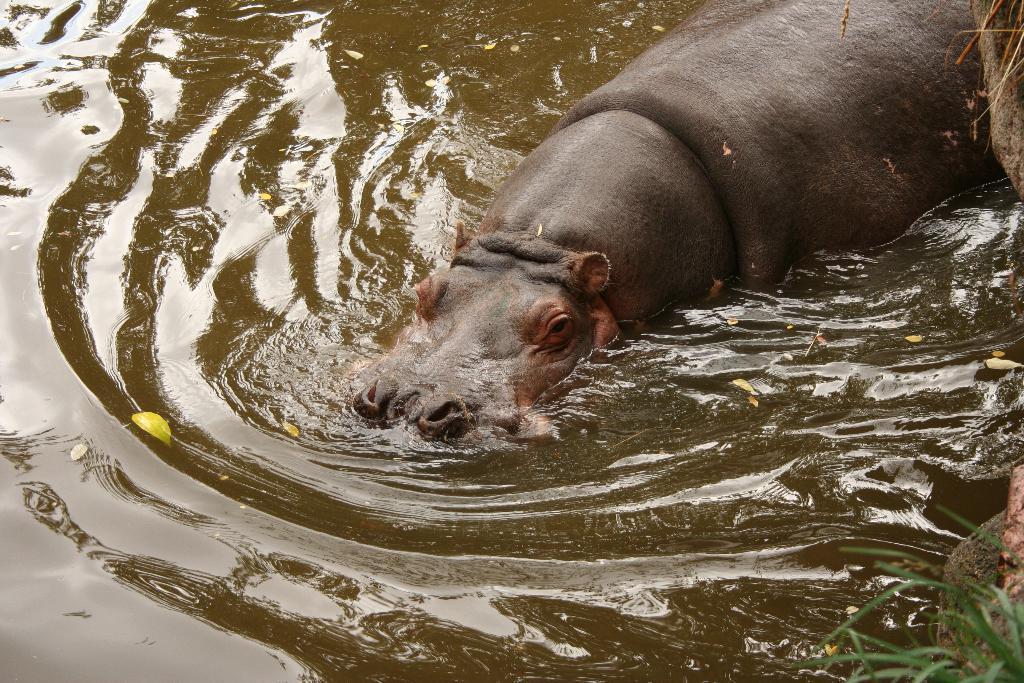How would you summarize this image in a sentence or two? This image consists of a hippopotamus in the water. At the bottom, there is water. At the bottom right, there is a grass. 